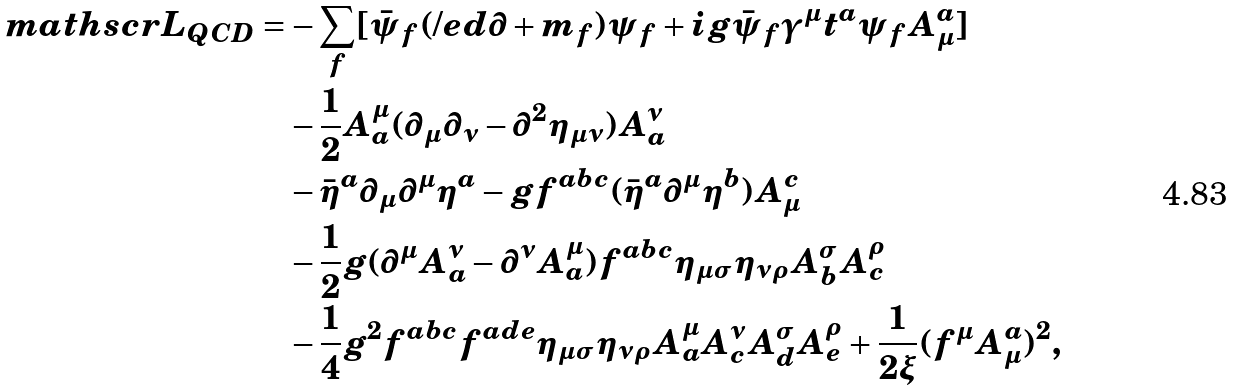<formula> <loc_0><loc_0><loc_500><loc_500>\ m a t h s c r { L } _ { Q C D } = & - \sum _ { f } [ \bar { \psi } _ { f } ( \slash e d { \partial } + m _ { f } ) \psi _ { f } + i g \bar { \psi } _ { f } \gamma ^ { \mu } t ^ { a } \psi _ { f } A _ { \mu } ^ { a } ] \\ & - \frac { 1 } { 2 } A _ { a } ^ { \mu } ( \partial _ { \mu } \partial _ { \nu } - \partial ^ { 2 } \eta _ { \mu \nu } ) A _ { a } ^ { \nu } \\ & - \bar { \eta } ^ { a } \partial _ { \mu } \partial ^ { \mu } \eta ^ { a } - g f ^ { a b c } ( \bar { \eta } ^ { a } \partial ^ { \mu } \eta ^ { b } ) A _ { \mu } ^ { c } \\ & - \frac { 1 } { 2 } g ( \partial ^ { \mu } A _ { a } ^ { \nu } - \partial ^ { \nu } A _ { a } ^ { \mu } ) f ^ { a b c } \eta _ { \mu \sigma } \eta _ { \nu \rho } A _ { b } ^ { \sigma } A _ { c } ^ { \rho } \\ & - \frac { 1 } { 4 } g ^ { 2 } f ^ { a b c } f ^ { a d e } \eta _ { \mu \sigma } \eta _ { \nu \rho } A _ { a } ^ { \mu } A _ { c } ^ { \nu } A _ { d } ^ { \sigma } A _ { e } ^ { \rho } + \frac { 1 } { 2 \xi } ( f ^ { \mu } A _ { \mu } ^ { a } ) ^ { 2 } ,</formula> 